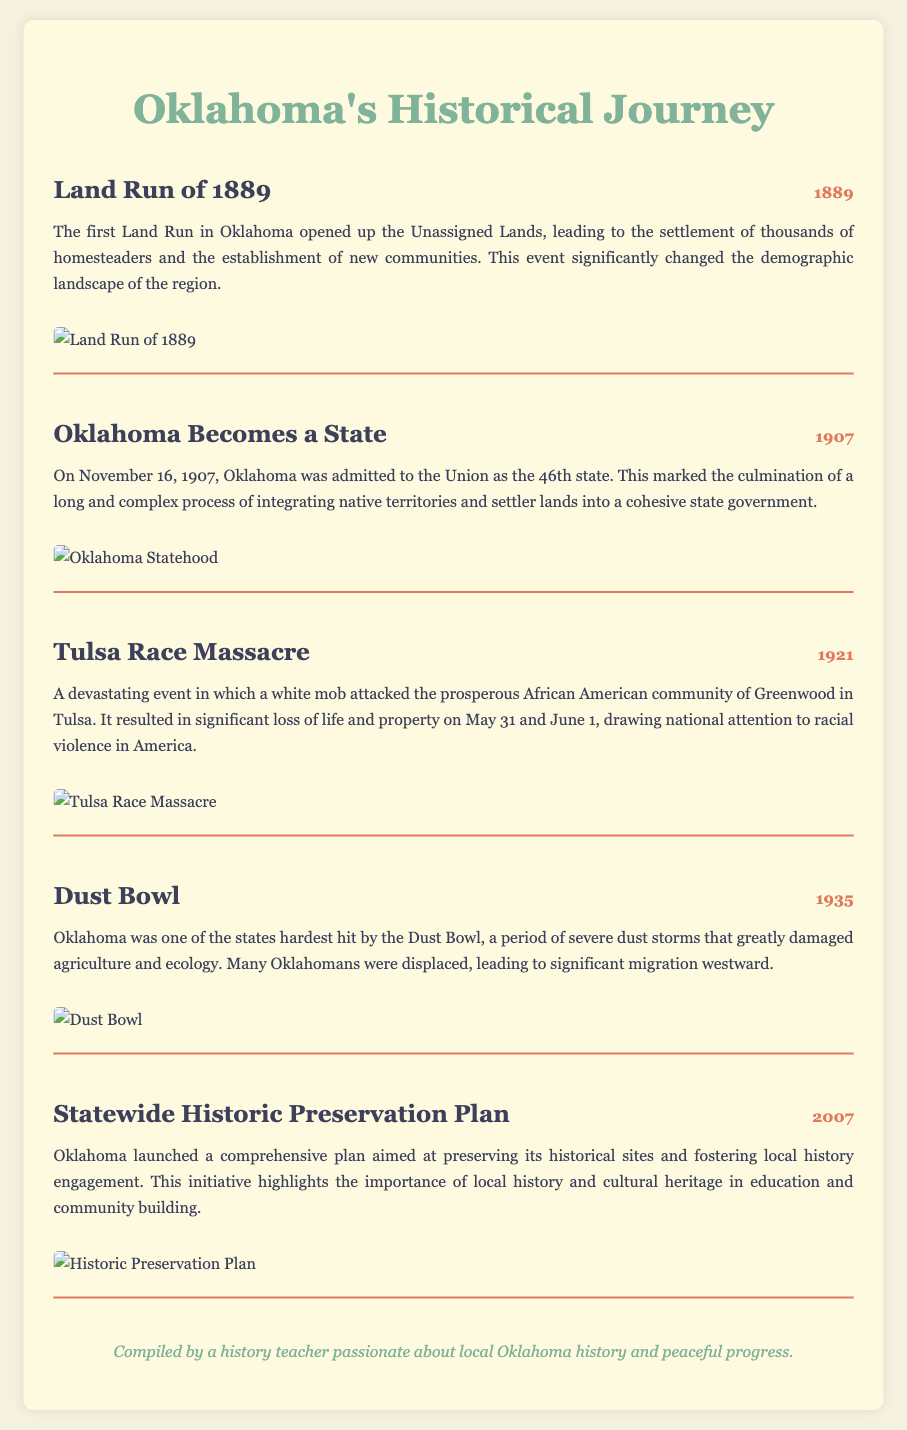What year did the Land Run take place? The year of the Land Run is explicitly stated as 1889 in the event description.
Answer: 1889 What was a significant event that occurred in Oklahoma in 1907? The event for 1907 mentioned in the document is Oklahoma's admission as a state.
Answer: Oklahoma Becomes a State What does the event description of the Tulsa Race Massacre highlight? The description of the Tulsa Race Massacre indicates it involved a white mob attacking the Greenwood community due to racial violence.
Answer: Racial violence Which catastrophic agricultural event affected Oklahoma in 1935? The document mentions the Dust Bowl as the significant agricultural event that occurred in 1935.
Answer: Dust Bowl What was launched in Oklahoma in 2007? The document indicates that a Statewide Historic Preservation Plan was launched in 2007.
Answer: Statewide Historic Preservation Plan How did the Land Run of 1889 change the demographic landscape? The description states that it led to the settlement of thousands of homesteaders and the establishment of new communities.
Answer: New communities In which city did the Tulsa Race Massacre occur? The event description specifically states that it took place in Tulsa.
Answer: Tulsa What is the primary focus of the Statewide Historic Preservation Plan? The description emphasizes the importance of preserving historical sites and fostering local history engagement.
Answer: Preserving historical sites 